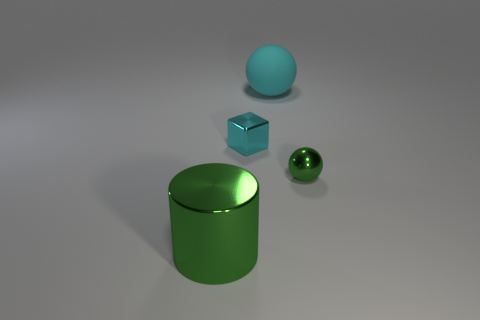Add 3 large metal objects. How many objects exist? 7 Subtract all cubes. How many objects are left? 3 Subtract 0 brown cubes. How many objects are left? 4 Subtract all tiny spheres. Subtract all small green metallic spheres. How many objects are left? 2 Add 3 small cyan metal cubes. How many small cyan metal cubes are left? 4 Add 4 large red metal spheres. How many large red metal spheres exist? 4 